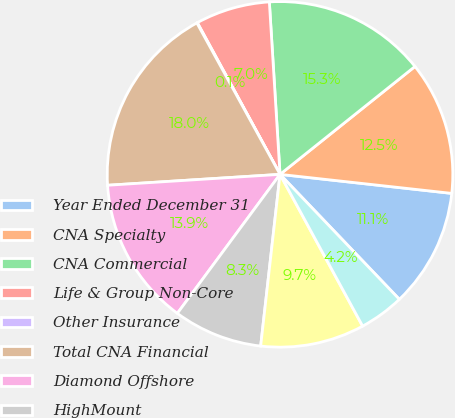Convert chart. <chart><loc_0><loc_0><loc_500><loc_500><pie_chart><fcel>Year Ended December 31<fcel>CNA Specialty<fcel>CNA Commercial<fcel>Life & Group Non-Core<fcel>Other Insurance<fcel>Total CNA Financial<fcel>Diamond Offshore<fcel>HighMount<fcel>Boardwalk Pipeline<fcel>Loews Hotels<nl><fcel>11.11%<fcel>12.49%<fcel>15.25%<fcel>6.96%<fcel>0.05%<fcel>18.01%<fcel>13.87%<fcel>8.34%<fcel>9.72%<fcel>4.2%<nl></chart> 